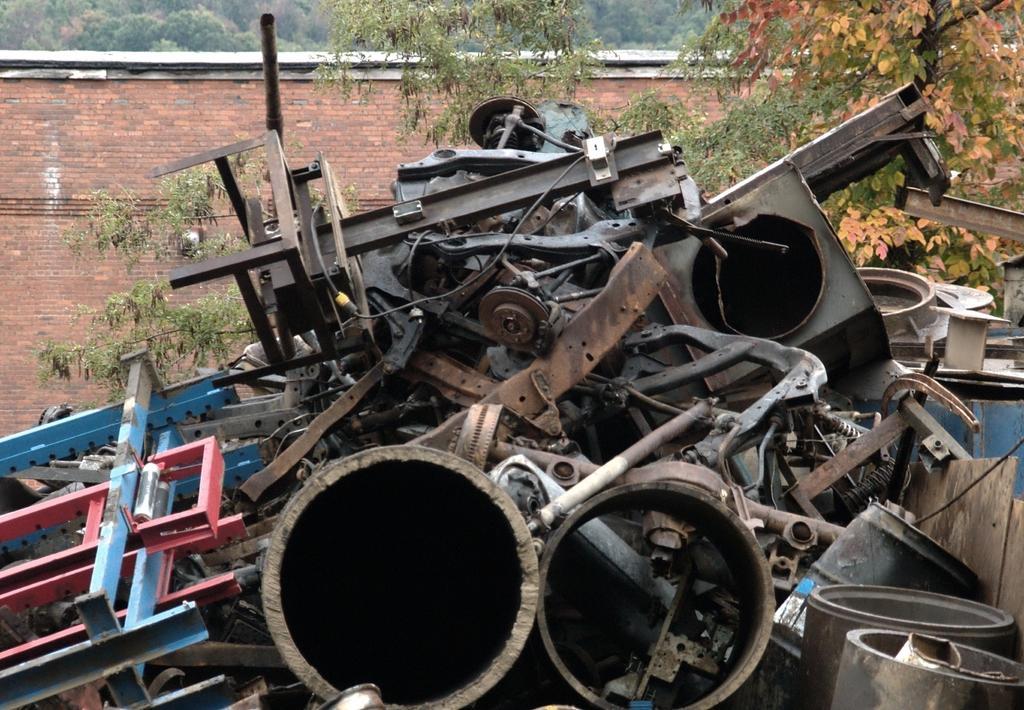How would you summarize this image in a sentence or two? In this picture I can see scrap items, there is a wall and there are trees. 